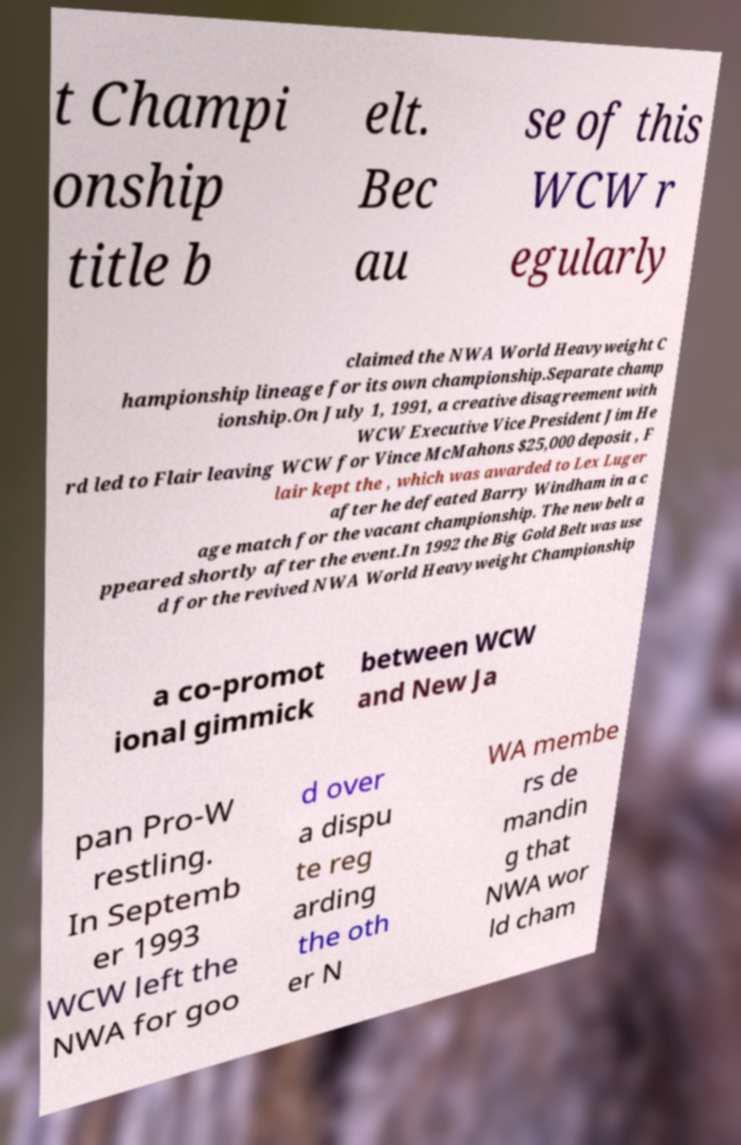Please read and relay the text visible in this image. What does it say? t Champi onship title b elt. Bec au se of this WCW r egularly claimed the NWA World Heavyweight C hampionship lineage for its own championship.Separate champ ionship.On July 1, 1991, a creative disagreement with WCW Executive Vice President Jim He rd led to Flair leaving WCW for Vince McMahons $25,000 deposit , F lair kept the , which was awarded to Lex Luger after he defeated Barry Windham in a c age match for the vacant championship. The new belt a ppeared shortly after the event.In 1992 the Big Gold Belt was use d for the revived NWA World Heavyweight Championship a co-promot ional gimmick between WCW and New Ja pan Pro-W restling. In Septemb er 1993 WCW left the NWA for goo d over a dispu te reg arding the oth er N WA membe rs de mandin g that NWA wor ld cham 